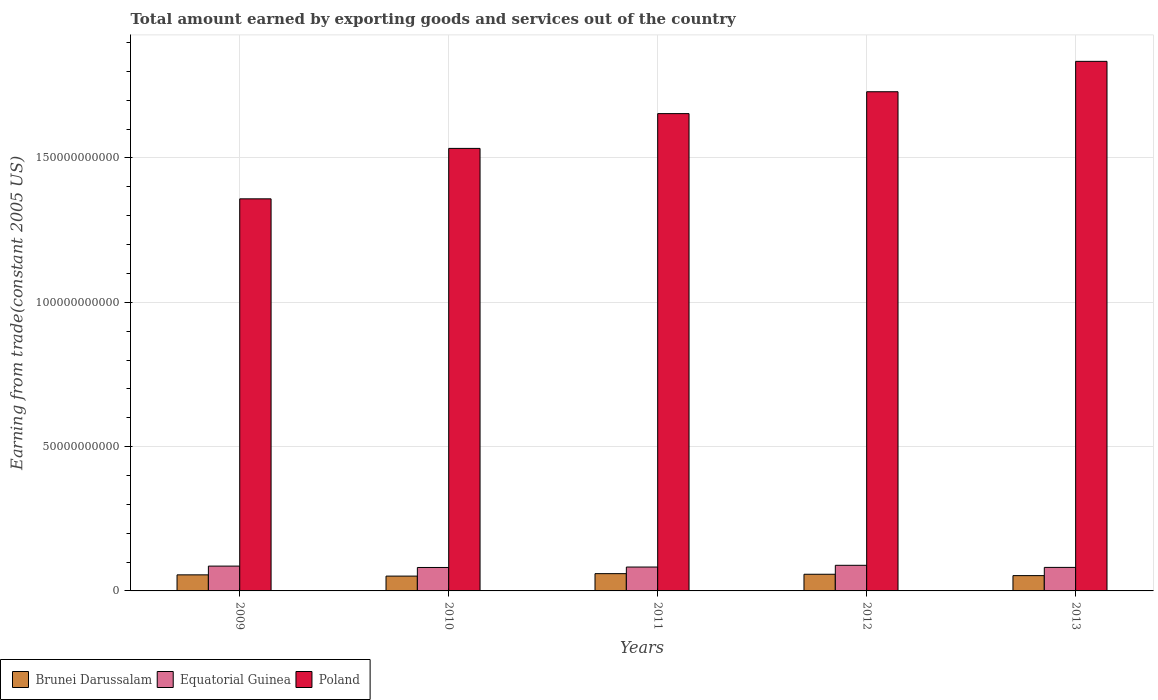How many different coloured bars are there?
Provide a succinct answer. 3. Are the number of bars on each tick of the X-axis equal?
Provide a short and direct response. Yes. How many bars are there on the 4th tick from the left?
Your response must be concise. 3. What is the label of the 3rd group of bars from the left?
Keep it short and to the point. 2011. In how many cases, is the number of bars for a given year not equal to the number of legend labels?
Make the answer very short. 0. What is the total amount earned by exporting goods and services in Brunei Darussalam in 2009?
Ensure brevity in your answer.  5.57e+09. Across all years, what is the maximum total amount earned by exporting goods and services in Brunei Darussalam?
Provide a short and direct response. 5.99e+09. Across all years, what is the minimum total amount earned by exporting goods and services in Poland?
Your answer should be very brief. 1.36e+11. In which year was the total amount earned by exporting goods and services in Equatorial Guinea maximum?
Ensure brevity in your answer.  2012. What is the total total amount earned by exporting goods and services in Equatorial Guinea in the graph?
Your response must be concise. 4.20e+1. What is the difference between the total amount earned by exporting goods and services in Brunei Darussalam in 2010 and that in 2013?
Your answer should be compact. -1.68e+08. What is the difference between the total amount earned by exporting goods and services in Equatorial Guinea in 2010 and the total amount earned by exporting goods and services in Brunei Darussalam in 2013?
Make the answer very short. 2.82e+09. What is the average total amount earned by exporting goods and services in Brunei Darussalam per year?
Offer a terse response. 5.55e+09. In the year 2010, what is the difference between the total amount earned by exporting goods and services in Poland and total amount earned by exporting goods and services in Equatorial Guinea?
Your response must be concise. 1.45e+11. What is the ratio of the total amount earned by exporting goods and services in Poland in 2011 to that in 2012?
Give a very brief answer. 0.96. Is the total amount earned by exporting goods and services in Poland in 2011 less than that in 2013?
Keep it short and to the point. Yes. Is the difference between the total amount earned by exporting goods and services in Poland in 2010 and 2012 greater than the difference between the total amount earned by exporting goods and services in Equatorial Guinea in 2010 and 2012?
Your response must be concise. No. What is the difference between the highest and the second highest total amount earned by exporting goods and services in Poland?
Make the answer very short. 1.05e+1. What is the difference between the highest and the lowest total amount earned by exporting goods and services in Poland?
Make the answer very short. 4.76e+1. In how many years, is the total amount earned by exporting goods and services in Poland greater than the average total amount earned by exporting goods and services in Poland taken over all years?
Provide a succinct answer. 3. What does the 1st bar from the left in 2012 represents?
Provide a short and direct response. Brunei Darussalam. What does the 3rd bar from the right in 2010 represents?
Your response must be concise. Brunei Darussalam. How many bars are there?
Make the answer very short. 15. Are the values on the major ticks of Y-axis written in scientific E-notation?
Your answer should be very brief. No. Does the graph contain grids?
Your answer should be compact. Yes. How many legend labels are there?
Provide a short and direct response. 3. How are the legend labels stacked?
Ensure brevity in your answer.  Horizontal. What is the title of the graph?
Your response must be concise. Total amount earned by exporting goods and services out of the country. Does "East Asia (all income levels)" appear as one of the legend labels in the graph?
Offer a terse response. No. What is the label or title of the Y-axis?
Keep it short and to the point. Earning from trade(constant 2005 US). What is the Earning from trade(constant 2005 US) of Brunei Darussalam in 2009?
Ensure brevity in your answer.  5.57e+09. What is the Earning from trade(constant 2005 US) of Equatorial Guinea in 2009?
Ensure brevity in your answer.  8.60e+09. What is the Earning from trade(constant 2005 US) in Poland in 2009?
Give a very brief answer. 1.36e+11. What is the Earning from trade(constant 2005 US) of Brunei Darussalam in 2010?
Your response must be concise. 5.13e+09. What is the Earning from trade(constant 2005 US) in Equatorial Guinea in 2010?
Make the answer very short. 8.12e+09. What is the Earning from trade(constant 2005 US) of Poland in 2010?
Ensure brevity in your answer.  1.53e+11. What is the Earning from trade(constant 2005 US) in Brunei Darussalam in 2011?
Offer a very short reply. 5.99e+09. What is the Earning from trade(constant 2005 US) in Equatorial Guinea in 2011?
Keep it short and to the point. 8.27e+09. What is the Earning from trade(constant 2005 US) in Poland in 2011?
Your answer should be compact. 1.65e+11. What is the Earning from trade(constant 2005 US) of Brunei Darussalam in 2012?
Keep it short and to the point. 5.77e+09. What is the Earning from trade(constant 2005 US) of Equatorial Guinea in 2012?
Keep it short and to the point. 8.88e+09. What is the Earning from trade(constant 2005 US) in Poland in 2012?
Make the answer very short. 1.73e+11. What is the Earning from trade(constant 2005 US) in Brunei Darussalam in 2013?
Keep it short and to the point. 5.30e+09. What is the Earning from trade(constant 2005 US) of Equatorial Guinea in 2013?
Ensure brevity in your answer.  8.15e+09. What is the Earning from trade(constant 2005 US) of Poland in 2013?
Give a very brief answer. 1.83e+11. Across all years, what is the maximum Earning from trade(constant 2005 US) in Brunei Darussalam?
Your answer should be compact. 5.99e+09. Across all years, what is the maximum Earning from trade(constant 2005 US) of Equatorial Guinea?
Offer a very short reply. 8.88e+09. Across all years, what is the maximum Earning from trade(constant 2005 US) of Poland?
Your answer should be very brief. 1.83e+11. Across all years, what is the minimum Earning from trade(constant 2005 US) in Brunei Darussalam?
Offer a very short reply. 5.13e+09. Across all years, what is the minimum Earning from trade(constant 2005 US) in Equatorial Guinea?
Keep it short and to the point. 8.12e+09. Across all years, what is the minimum Earning from trade(constant 2005 US) of Poland?
Ensure brevity in your answer.  1.36e+11. What is the total Earning from trade(constant 2005 US) in Brunei Darussalam in the graph?
Provide a short and direct response. 2.78e+1. What is the total Earning from trade(constant 2005 US) of Equatorial Guinea in the graph?
Give a very brief answer. 4.20e+1. What is the total Earning from trade(constant 2005 US) in Poland in the graph?
Provide a succinct answer. 8.11e+11. What is the difference between the Earning from trade(constant 2005 US) of Brunei Darussalam in 2009 and that in 2010?
Make the answer very short. 4.34e+08. What is the difference between the Earning from trade(constant 2005 US) in Equatorial Guinea in 2009 and that in 2010?
Your response must be concise. 4.78e+08. What is the difference between the Earning from trade(constant 2005 US) of Poland in 2009 and that in 2010?
Your answer should be very brief. -1.75e+1. What is the difference between the Earning from trade(constant 2005 US) in Brunei Darussalam in 2009 and that in 2011?
Give a very brief answer. -4.20e+08. What is the difference between the Earning from trade(constant 2005 US) of Equatorial Guinea in 2009 and that in 2011?
Offer a very short reply. 3.28e+08. What is the difference between the Earning from trade(constant 2005 US) of Poland in 2009 and that in 2011?
Your response must be concise. -2.95e+1. What is the difference between the Earning from trade(constant 2005 US) of Brunei Darussalam in 2009 and that in 2012?
Your answer should be compact. -2.08e+08. What is the difference between the Earning from trade(constant 2005 US) in Equatorial Guinea in 2009 and that in 2012?
Ensure brevity in your answer.  -2.77e+08. What is the difference between the Earning from trade(constant 2005 US) in Poland in 2009 and that in 2012?
Offer a terse response. -3.71e+1. What is the difference between the Earning from trade(constant 2005 US) in Brunei Darussalam in 2009 and that in 2013?
Offer a terse response. 2.66e+08. What is the difference between the Earning from trade(constant 2005 US) of Equatorial Guinea in 2009 and that in 2013?
Provide a short and direct response. 4.49e+08. What is the difference between the Earning from trade(constant 2005 US) of Poland in 2009 and that in 2013?
Offer a very short reply. -4.76e+1. What is the difference between the Earning from trade(constant 2005 US) in Brunei Darussalam in 2010 and that in 2011?
Your answer should be compact. -8.54e+08. What is the difference between the Earning from trade(constant 2005 US) of Equatorial Guinea in 2010 and that in 2011?
Provide a succinct answer. -1.50e+08. What is the difference between the Earning from trade(constant 2005 US) in Poland in 2010 and that in 2011?
Your answer should be very brief. -1.21e+1. What is the difference between the Earning from trade(constant 2005 US) of Brunei Darussalam in 2010 and that in 2012?
Your answer should be compact. -6.42e+08. What is the difference between the Earning from trade(constant 2005 US) of Equatorial Guinea in 2010 and that in 2012?
Your answer should be very brief. -7.55e+08. What is the difference between the Earning from trade(constant 2005 US) of Poland in 2010 and that in 2012?
Make the answer very short. -1.96e+1. What is the difference between the Earning from trade(constant 2005 US) of Brunei Darussalam in 2010 and that in 2013?
Give a very brief answer. -1.68e+08. What is the difference between the Earning from trade(constant 2005 US) of Equatorial Guinea in 2010 and that in 2013?
Ensure brevity in your answer.  -2.90e+07. What is the difference between the Earning from trade(constant 2005 US) in Poland in 2010 and that in 2013?
Make the answer very short. -3.02e+1. What is the difference between the Earning from trade(constant 2005 US) in Brunei Darussalam in 2011 and that in 2012?
Keep it short and to the point. 2.13e+08. What is the difference between the Earning from trade(constant 2005 US) of Equatorial Guinea in 2011 and that in 2012?
Offer a very short reply. -6.05e+08. What is the difference between the Earning from trade(constant 2005 US) in Poland in 2011 and that in 2012?
Offer a very short reply. -7.58e+09. What is the difference between the Earning from trade(constant 2005 US) in Brunei Darussalam in 2011 and that in 2013?
Offer a terse response. 6.87e+08. What is the difference between the Earning from trade(constant 2005 US) in Equatorial Guinea in 2011 and that in 2013?
Keep it short and to the point. 1.21e+08. What is the difference between the Earning from trade(constant 2005 US) of Poland in 2011 and that in 2013?
Make the answer very short. -1.81e+1. What is the difference between the Earning from trade(constant 2005 US) in Brunei Darussalam in 2012 and that in 2013?
Your answer should be compact. 4.74e+08. What is the difference between the Earning from trade(constant 2005 US) of Equatorial Guinea in 2012 and that in 2013?
Provide a succinct answer. 7.26e+08. What is the difference between the Earning from trade(constant 2005 US) in Poland in 2012 and that in 2013?
Your response must be concise. -1.05e+1. What is the difference between the Earning from trade(constant 2005 US) in Brunei Darussalam in 2009 and the Earning from trade(constant 2005 US) in Equatorial Guinea in 2010?
Give a very brief answer. -2.56e+09. What is the difference between the Earning from trade(constant 2005 US) in Brunei Darussalam in 2009 and the Earning from trade(constant 2005 US) in Poland in 2010?
Your response must be concise. -1.48e+11. What is the difference between the Earning from trade(constant 2005 US) in Equatorial Guinea in 2009 and the Earning from trade(constant 2005 US) in Poland in 2010?
Your answer should be compact. -1.45e+11. What is the difference between the Earning from trade(constant 2005 US) in Brunei Darussalam in 2009 and the Earning from trade(constant 2005 US) in Equatorial Guinea in 2011?
Provide a short and direct response. -2.71e+09. What is the difference between the Earning from trade(constant 2005 US) of Brunei Darussalam in 2009 and the Earning from trade(constant 2005 US) of Poland in 2011?
Make the answer very short. -1.60e+11. What is the difference between the Earning from trade(constant 2005 US) of Equatorial Guinea in 2009 and the Earning from trade(constant 2005 US) of Poland in 2011?
Keep it short and to the point. -1.57e+11. What is the difference between the Earning from trade(constant 2005 US) in Brunei Darussalam in 2009 and the Earning from trade(constant 2005 US) in Equatorial Guinea in 2012?
Provide a short and direct response. -3.31e+09. What is the difference between the Earning from trade(constant 2005 US) of Brunei Darussalam in 2009 and the Earning from trade(constant 2005 US) of Poland in 2012?
Offer a terse response. -1.67e+11. What is the difference between the Earning from trade(constant 2005 US) in Equatorial Guinea in 2009 and the Earning from trade(constant 2005 US) in Poland in 2012?
Make the answer very short. -1.64e+11. What is the difference between the Earning from trade(constant 2005 US) in Brunei Darussalam in 2009 and the Earning from trade(constant 2005 US) in Equatorial Guinea in 2013?
Make the answer very short. -2.59e+09. What is the difference between the Earning from trade(constant 2005 US) in Brunei Darussalam in 2009 and the Earning from trade(constant 2005 US) in Poland in 2013?
Ensure brevity in your answer.  -1.78e+11. What is the difference between the Earning from trade(constant 2005 US) of Equatorial Guinea in 2009 and the Earning from trade(constant 2005 US) of Poland in 2013?
Give a very brief answer. -1.75e+11. What is the difference between the Earning from trade(constant 2005 US) of Brunei Darussalam in 2010 and the Earning from trade(constant 2005 US) of Equatorial Guinea in 2011?
Your response must be concise. -3.14e+09. What is the difference between the Earning from trade(constant 2005 US) in Brunei Darussalam in 2010 and the Earning from trade(constant 2005 US) in Poland in 2011?
Give a very brief answer. -1.60e+11. What is the difference between the Earning from trade(constant 2005 US) in Equatorial Guinea in 2010 and the Earning from trade(constant 2005 US) in Poland in 2011?
Offer a very short reply. -1.57e+11. What is the difference between the Earning from trade(constant 2005 US) of Brunei Darussalam in 2010 and the Earning from trade(constant 2005 US) of Equatorial Guinea in 2012?
Give a very brief answer. -3.75e+09. What is the difference between the Earning from trade(constant 2005 US) of Brunei Darussalam in 2010 and the Earning from trade(constant 2005 US) of Poland in 2012?
Your answer should be very brief. -1.68e+11. What is the difference between the Earning from trade(constant 2005 US) in Equatorial Guinea in 2010 and the Earning from trade(constant 2005 US) in Poland in 2012?
Your response must be concise. -1.65e+11. What is the difference between the Earning from trade(constant 2005 US) of Brunei Darussalam in 2010 and the Earning from trade(constant 2005 US) of Equatorial Guinea in 2013?
Give a very brief answer. -3.02e+09. What is the difference between the Earning from trade(constant 2005 US) of Brunei Darussalam in 2010 and the Earning from trade(constant 2005 US) of Poland in 2013?
Your response must be concise. -1.78e+11. What is the difference between the Earning from trade(constant 2005 US) of Equatorial Guinea in 2010 and the Earning from trade(constant 2005 US) of Poland in 2013?
Offer a very short reply. -1.75e+11. What is the difference between the Earning from trade(constant 2005 US) of Brunei Darussalam in 2011 and the Earning from trade(constant 2005 US) of Equatorial Guinea in 2012?
Give a very brief answer. -2.89e+09. What is the difference between the Earning from trade(constant 2005 US) in Brunei Darussalam in 2011 and the Earning from trade(constant 2005 US) in Poland in 2012?
Offer a terse response. -1.67e+11. What is the difference between the Earning from trade(constant 2005 US) of Equatorial Guinea in 2011 and the Earning from trade(constant 2005 US) of Poland in 2012?
Offer a very short reply. -1.65e+11. What is the difference between the Earning from trade(constant 2005 US) of Brunei Darussalam in 2011 and the Earning from trade(constant 2005 US) of Equatorial Guinea in 2013?
Your answer should be compact. -2.17e+09. What is the difference between the Earning from trade(constant 2005 US) of Brunei Darussalam in 2011 and the Earning from trade(constant 2005 US) of Poland in 2013?
Your answer should be compact. -1.77e+11. What is the difference between the Earning from trade(constant 2005 US) in Equatorial Guinea in 2011 and the Earning from trade(constant 2005 US) in Poland in 2013?
Provide a short and direct response. -1.75e+11. What is the difference between the Earning from trade(constant 2005 US) in Brunei Darussalam in 2012 and the Earning from trade(constant 2005 US) in Equatorial Guinea in 2013?
Provide a short and direct response. -2.38e+09. What is the difference between the Earning from trade(constant 2005 US) in Brunei Darussalam in 2012 and the Earning from trade(constant 2005 US) in Poland in 2013?
Your response must be concise. -1.78e+11. What is the difference between the Earning from trade(constant 2005 US) of Equatorial Guinea in 2012 and the Earning from trade(constant 2005 US) of Poland in 2013?
Your answer should be very brief. -1.75e+11. What is the average Earning from trade(constant 2005 US) in Brunei Darussalam per year?
Offer a very short reply. 5.55e+09. What is the average Earning from trade(constant 2005 US) in Equatorial Guinea per year?
Provide a succinct answer. 8.41e+09. What is the average Earning from trade(constant 2005 US) of Poland per year?
Give a very brief answer. 1.62e+11. In the year 2009, what is the difference between the Earning from trade(constant 2005 US) of Brunei Darussalam and Earning from trade(constant 2005 US) of Equatorial Guinea?
Ensure brevity in your answer.  -3.03e+09. In the year 2009, what is the difference between the Earning from trade(constant 2005 US) in Brunei Darussalam and Earning from trade(constant 2005 US) in Poland?
Provide a succinct answer. -1.30e+11. In the year 2009, what is the difference between the Earning from trade(constant 2005 US) in Equatorial Guinea and Earning from trade(constant 2005 US) in Poland?
Your response must be concise. -1.27e+11. In the year 2010, what is the difference between the Earning from trade(constant 2005 US) of Brunei Darussalam and Earning from trade(constant 2005 US) of Equatorial Guinea?
Your answer should be compact. -2.99e+09. In the year 2010, what is the difference between the Earning from trade(constant 2005 US) in Brunei Darussalam and Earning from trade(constant 2005 US) in Poland?
Offer a very short reply. -1.48e+11. In the year 2010, what is the difference between the Earning from trade(constant 2005 US) in Equatorial Guinea and Earning from trade(constant 2005 US) in Poland?
Make the answer very short. -1.45e+11. In the year 2011, what is the difference between the Earning from trade(constant 2005 US) of Brunei Darussalam and Earning from trade(constant 2005 US) of Equatorial Guinea?
Offer a terse response. -2.29e+09. In the year 2011, what is the difference between the Earning from trade(constant 2005 US) of Brunei Darussalam and Earning from trade(constant 2005 US) of Poland?
Make the answer very short. -1.59e+11. In the year 2011, what is the difference between the Earning from trade(constant 2005 US) of Equatorial Guinea and Earning from trade(constant 2005 US) of Poland?
Your answer should be compact. -1.57e+11. In the year 2012, what is the difference between the Earning from trade(constant 2005 US) of Brunei Darussalam and Earning from trade(constant 2005 US) of Equatorial Guinea?
Offer a very short reply. -3.10e+09. In the year 2012, what is the difference between the Earning from trade(constant 2005 US) of Brunei Darussalam and Earning from trade(constant 2005 US) of Poland?
Offer a very short reply. -1.67e+11. In the year 2012, what is the difference between the Earning from trade(constant 2005 US) in Equatorial Guinea and Earning from trade(constant 2005 US) in Poland?
Your answer should be compact. -1.64e+11. In the year 2013, what is the difference between the Earning from trade(constant 2005 US) of Brunei Darussalam and Earning from trade(constant 2005 US) of Equatorial Guinea?
Keep it short and to the point. -2.85e+09. In the year 2013, what is the difference between the Earning from trade(constant 2005 US) in Brunei Darussalam and Earning from trade(constant 2005 US) in Poland?
Offer a very short reply. -1.78e+11. In the year 2013, what is the difference between the Earning from trade(constant 2005 US) of Equatorial Guinea and Earning from trade(constant 2005 US) of Poland?
Your answer should be very brief. -1.75e+11. What is the ratio of the Earning from trade(constant 2005 US) in Brunei Darussalam in 2009 to that in 2010?
Keep it short and to the point. 1.08. What is the ratio of the Earning from trade(constant 2005 US) in Equatorial Guinea in 2009 to that in 2010?
Give a very brief answer. 1.06. What is the ratio of the Earning from trade(constant 2005 US) of Poland in 2009 to that in 2010?
Keep it short and to the point. 0.89. What is the ratio of the Earning from trade(constant 2005 US) of Brunei Darussalam in 2009 to that in 2011?
Your answer should be very brief. 0.93. What is the ratio of the Earning from trade(constant 2005 US) in Equatorial Guinea in 2009 to that in 2011?
Your response must be concise. 1.04. What is the ratio of the Earning from trade(constant 2005 US) in Poland in 2009 to that in 2011?
Give a very brief answer. 0.82. What is the ratio of the Earning from trade(constant 2005 US) in Brunei Darussalam in 2009 to that in 2012?
Your answer should be very brief. 0.96. What is the ratio of the Earning from trade(constant 2005 US) in Equatorial Guinea in 2009 to that in 2012?
Give a very brief answer. 0.97. What is the ratio of the Earning from trade(constant 2005 US) of Poland in 2009 to that in 2012?
Give a very brief answer. 0.79. What is the ratio of the Earning from trade(constant 2005 US) of Brunei Darussalam in 2009 to that in 2013?
Offer a very short reply. 1.05. What is the ratio of the Earning from trade(constant 2005 US) in Equatorial Guinea in 2009 to that in 2013?
Make the answer very short. 1.05. What is the ratio of the Earning from trade(constant 2005 US) of Poland in 2009 to that in 2013?
Your answer should be very brief. 0.74. What is the ratio of the Earning from trade(constant 2005 US) in Brunei Darussalam in 2010 to that in 2011?
Ensure brevity in your answer.  0.86. What is the ratio of the Earning from trade(constant 2005 US) in Equatorial Guinea in 2010 to that in 2011?
Offer a terse response. 0.98. What is the ratio of the Earning from trade(constant 2005 US) of Poland in 2010 to that in 2011?
Offer a very short reply. 0.93. What is the ratio of the Earning from trade(constant 2005 US) in Brunei Darussalam in 2010 to that in 2012?
Your response must be concise. 0.89. What is the ratio of the Earning from trade(constant 2005 US) of Equatorial Guinea in 2010 to that in 2012?
Make the answer very short. 0.92. What is the ratio of the Earning from trade(constant 2005 US) in Poland in 2010 to that in 2012?
Your answer should be compact. 0.89. What is the ratio of the Earning from trade(constant 2005 US) of Brunei Darussalam in 2010 to that in 2013?
Your answer should be compact. 0.97. What is the ratio of the Earning from trade(constant 2005 US) in Poland in 2010 to that in 2013?
Your answer should be compact. 0.84. What is the ratio of the Earning from trade(constant 2005 US) in Brunei Darussalam in 2011 to that in 2012?
Give a very brief answer. 1.04. What is the ratio of the Earning from trade(constant 2005 US) in Equatorial Guinea in 2011 to that in 2012?
Make the answer very short. 0.93. What is the ratio of the Earning from trade(constant 2005 US) in Poland in 2011 to that in 2012?
Your answer should be very brief. 0.96. What is the ratio of the Earning from trade(constant 2005 US) in Brunei Darussalam in 2011 to that in 2013?
Give a very brief answer. 1.13. What is the ratio of the Earning from trade(constant 2005 US) in Equatorial Guinea in 2011 to that in 2013?
Keep it short and to the point. 1.01. What is the ratio of the Earning from trade(constant 2005 US) of Poland in 2011 to that in 2013?
Ensure brevity in your answer.  0.9. What is the ratio of the Earning from trade(constant 2005 US) of Brunei Darussalam in 2012 to that in 2013?
Your answer should be compact. 1.09. What is the ratio of the Earning from trade(constant 2005 US) in Equatorial Guinea in 2012 to that in 2013?
Your answer should be very brief. 1.09. What is the ratio of the Earning from trade(constant 2005 US) of Poland in 2012 to that in 2013?
Provide a succinct answer. 0.94. What is the difference between the highest and the second highest Earning from trade(constant 2005 US) in Brunei Darussalam?
Keep it short and to the point. 2.13e+08. What is the difference between the highest and the second highest Earning from trade(constant 2005 US) in Equatorial Guinea?
Your answer should be very brief. 2.77e+08. What is the difference between the highest and the second highest Earning from trade(constant 2005 US) in Poland?
Provide a short and direct response. 1.05e+1. What is the difference between the highest and the lowest Earning from trade(constant 2005 US) in Brunei Darussalam?
Give a very brief answer. 8.54e+08. What is the difference between the highest and the lowest Earning from trade(constant 2005 US) of Equatorial Guinea?
Offer a terse response. 7.55e+08. What is the difference between the highest and the lowest Earning from trade(constant 2005 US) of Poland?
Your answer should be very brief. 4.76e+1. 